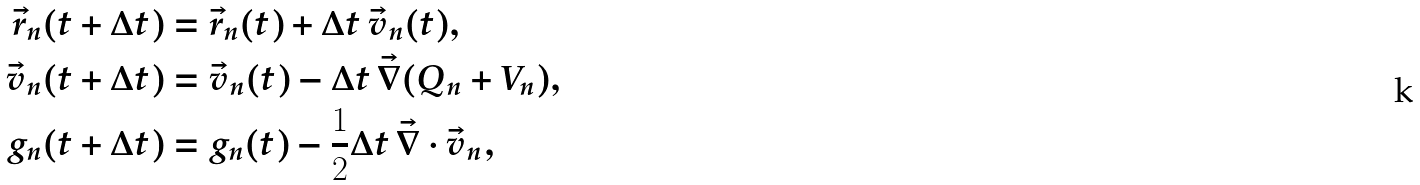Convert formula to latex. <formula><loc_0><loc_0><loc_500><loc_500>\vec { r } _ { n } ( t + \Delta t ) & = \vec { r } _ { n } ( t ) + \Delta t \, \vec { v } _ { n } ( t ) , \\ \vec { v } _ { n } ( t + \Delta t ) & = \vec { v } _ { n } ( t ) - \Delta t \, \vec { \nabla } ( Q _ { n } + V _ { n } ) , \\ g _ { n } ( t + \Delta t ) & = g _ { n } ( t ) - \frac { 1 } { 2 } \Delta t \, \vec { \nabla } \cdot \vec { v } _ { n } ,</formula> 